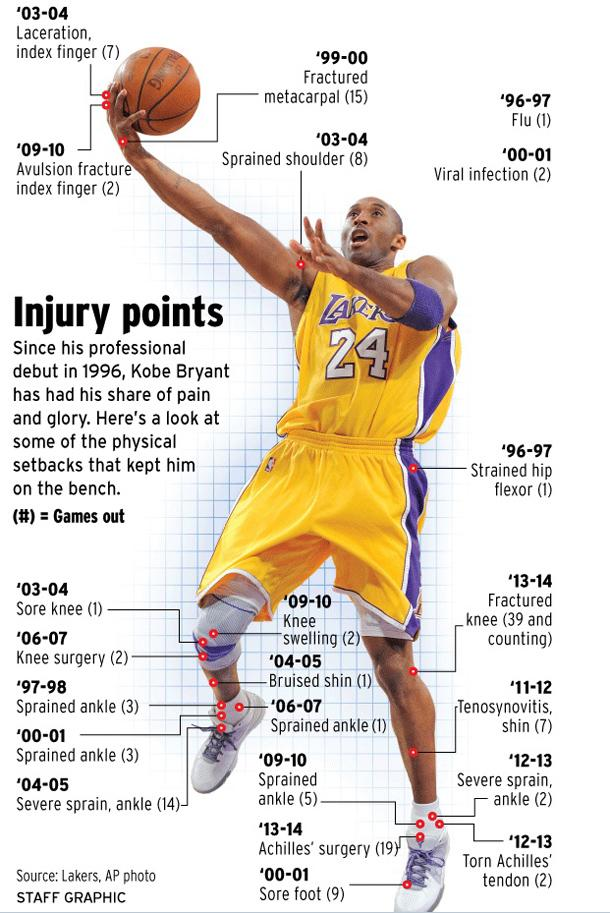Specify some key components in this picture. The individual had a sprained ankle 12 times, but it was not a severe injury. The individual has undergone both knee and Achilles surgery. In total, he underwent 21 surgeries. I am wearing jersey number 24, what is your jersey number? He had a severe sprain in his ankle 16 times. 